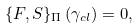Convert formula to latex. <formula><loc_0><loc_0><loc_500><loc_500>\{ F , S \} _ { \Pi } \, ( \gamma _ { c l } ) = 0 ,</formula> 